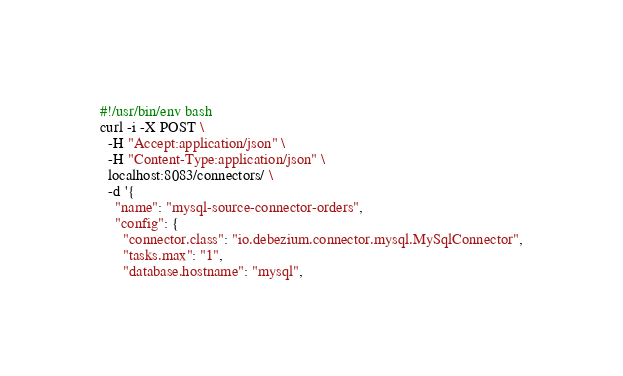<code> <loc_0><loc_0><loc_500><loc_500><_Bash_>#!/usr/bin/env bash
curl -i -X POST \
  -H "Accept:application/json" \
  -H "Content-Type:application/json" \
  localhost:8083/connectors/ \
  -d '{
    "name": "mysql-source-connector-orders",
    "config": {
      "connector.class": "io.debezium.connector.mysql.MySqlConnector",
      "tasks.max": "1",
      "database.hostname": "mysql",</code> 